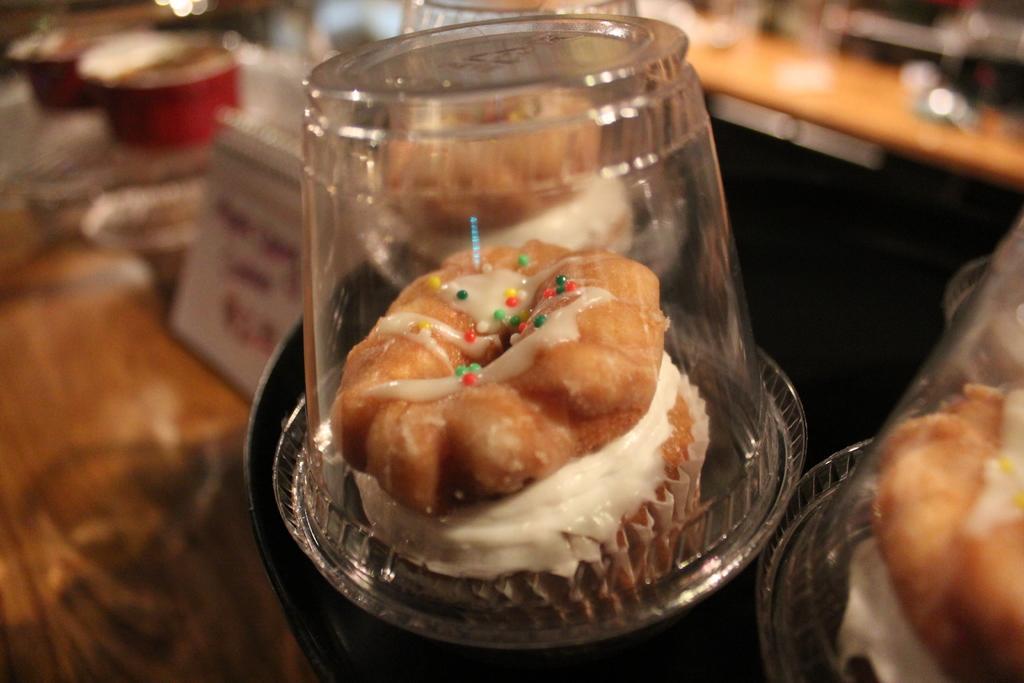Please provide a concise description of this image. In this picture, we see the cupcakes and glasses. At the bottom, we see a brown table on which the bowls are placed. In the background, we see a wooden table. This picture is blurred in the background. 